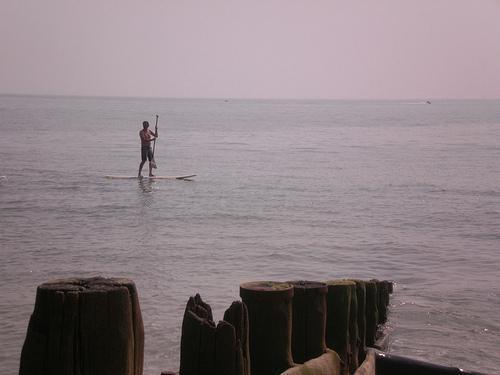How many people are there?
Give a very brief answer. 1. 